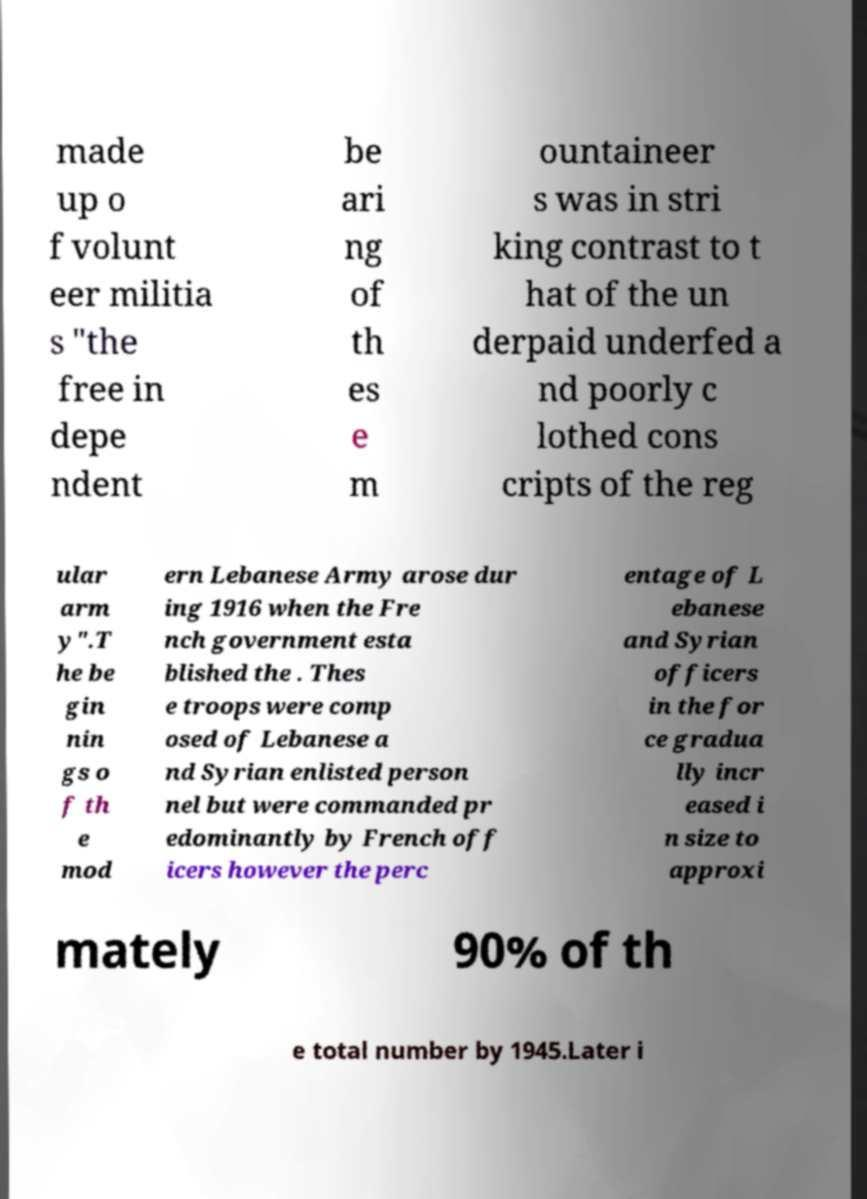Please read and relay the text visible in this image. What does it say? made up o f volunt eer militia s "the free in depe ndent be ari ng of th es e m ountaineer s was in stri king contrast to t hat of the un derpaid underfed a nd poorly c lothed cons cripts of the reg ular arm y".T he be gin nin gs o f th e mod ern Lebanese Army arose dur ing 1916 when the Fre nch government esta blished the . Thes e troops were comp osed of Lebanese a nd Syrian enlisted person nel but were commanded pr edominantly by French off icers however the perc entage of L ebanese and Syrian officers in the for ce gradua lly incr eased i n size to approxi mately 90% of th e total number by 1945.Later i 